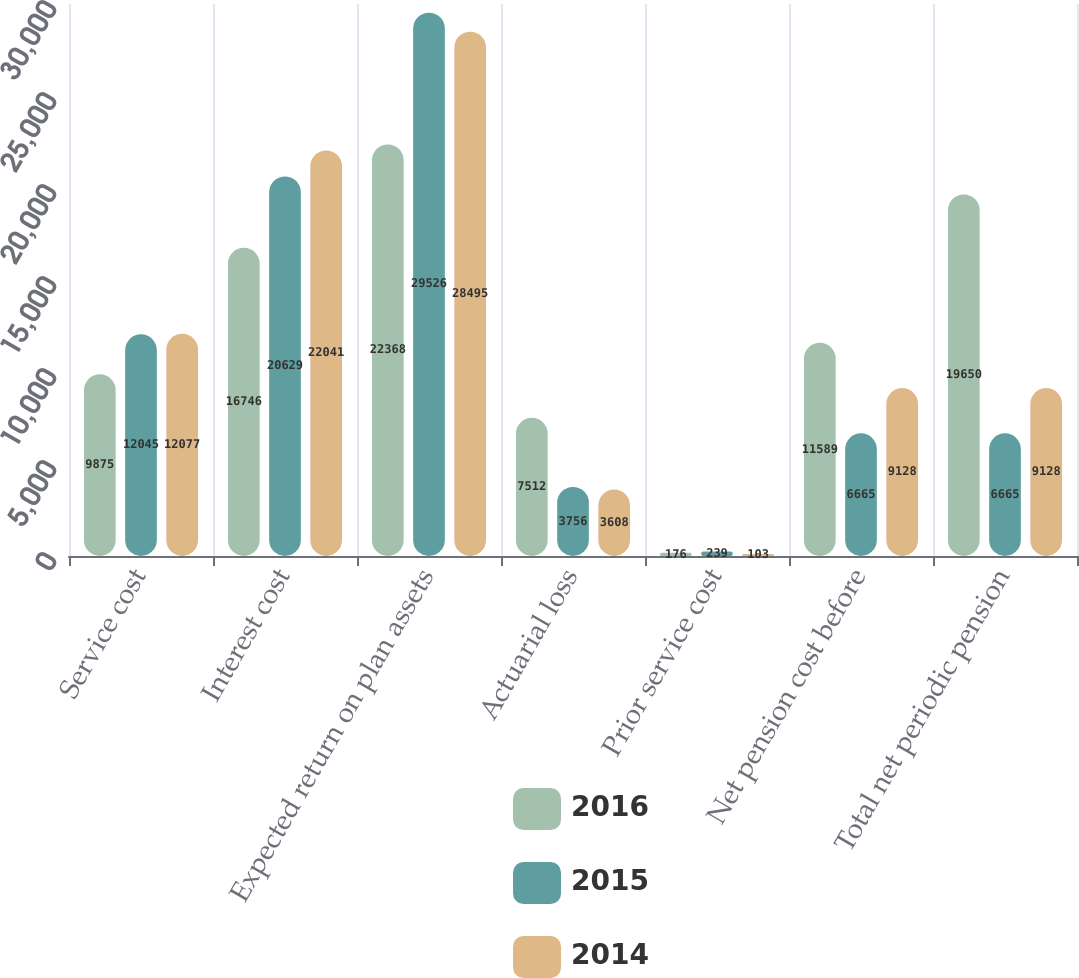Convert chart to OTSL. <chart><loc_0><loc_0><loc_500><loc_500><stacked_bar_chart><ecel><fcel>Service cost<fcel>Interest cost<fcel>Expected return on plan assets<fcel>Actuarial loss<fcel>Prior service cost<fcel>Net pension cost before<fcel>Total net periodic pension<nl><fcel>2016<fcel>9875<fcel>16746<fcel>22368<fcel>7512<fcel>176<fcel>11589<fcel>19650<nl><fcel>2015<fcel>12045<fcel>20629<fcel>29526<fcel>3756<fcel>239<fcel>6665<fcel>6665<nl><fcel>2014<fcel>12077<fcel>22041<fcel>28495<fcel>3608<fcel>103<fcel>9128<fcel>9128<nl></chart> 